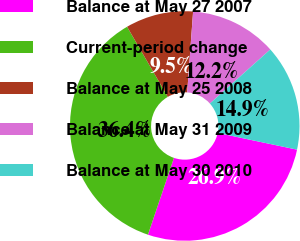<chart> <loc_0><loc_0><loc_500><loc_500><pie_chart><fcel>Balance at May 27 2007<fcel>Current-period change<fcel>Balance at May 25 2008<fcel>Balance at May 31 2009<fcel>Balance at May 30 2010<nl><fcel>26.89%<fcel>36.43%<fcel>9.54%<fcel>12.23%<fcel>14.92%<nl></chart> 